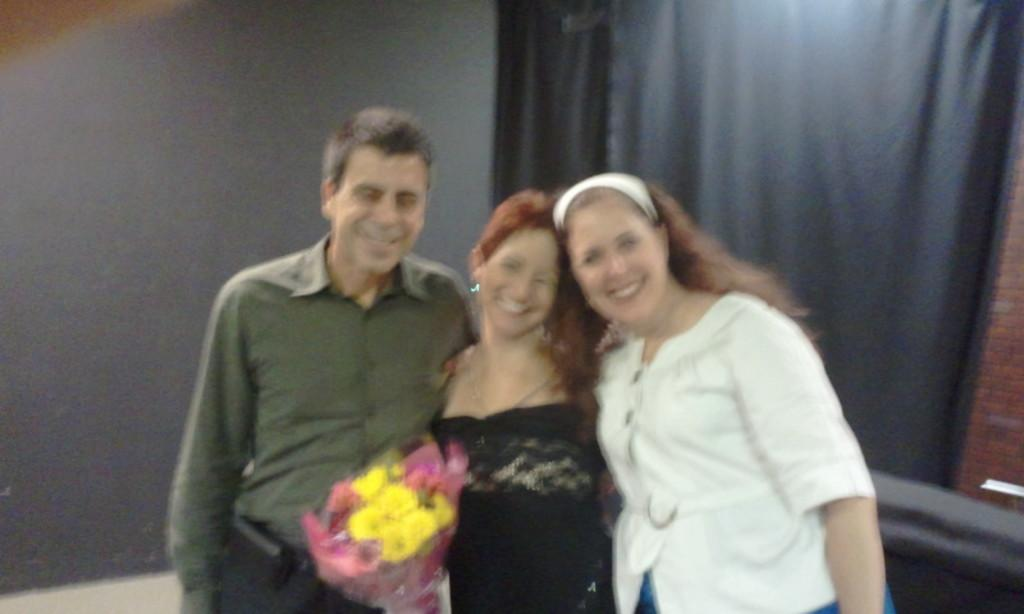How many people are present in the image? There are three people in the image. What is the middle person holding? The middle person is holding a bouquet. What can be seen in the background of the image? There is a wall in the background of the image. What is located beside the wall? There is a curtain beside the wall. What type of vessel is being used for the birth in the image? There is no vessel or birth depicted in the image; it features three people and a bouquet. How does the middle person hear the music in the image? There is no music or indication of hearing in the image; it only shows three people and a bouquet. 